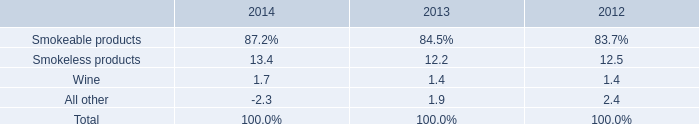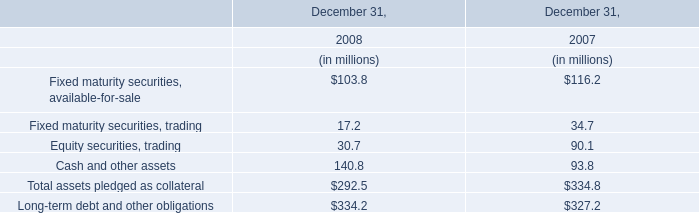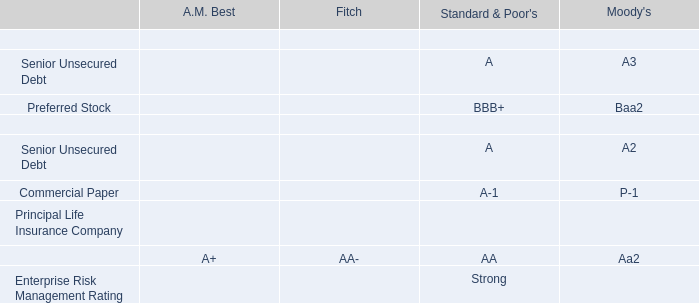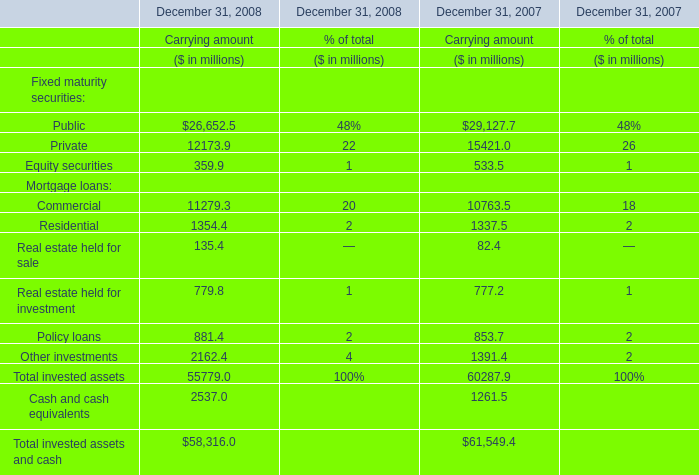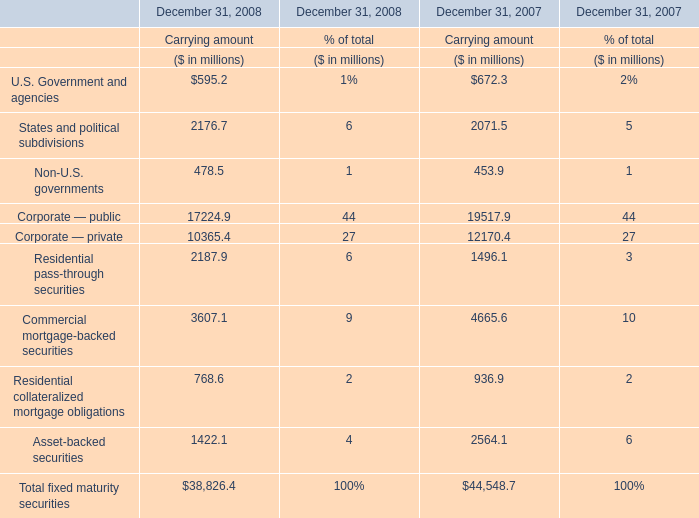how did the percentage of operating income related to smokeless product change from 2012 to 2013 relative the total operating income? 
Computations: ((12.2 - 12.5) / 12.5)
Answer: -0.024. 